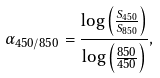<formula> <loc_0><loc_0><loc_500><loc_500>\alpha _ { 4 5 0 / 8 5 0 } = \frac { \log \left ( \frac { S _ { 4 5 0 } } { S _ { 8 5 0 } } \right ) } { \log \left ( \frac { 8 5 0 } { 4 5 0 } \right ) } ,</formula> 